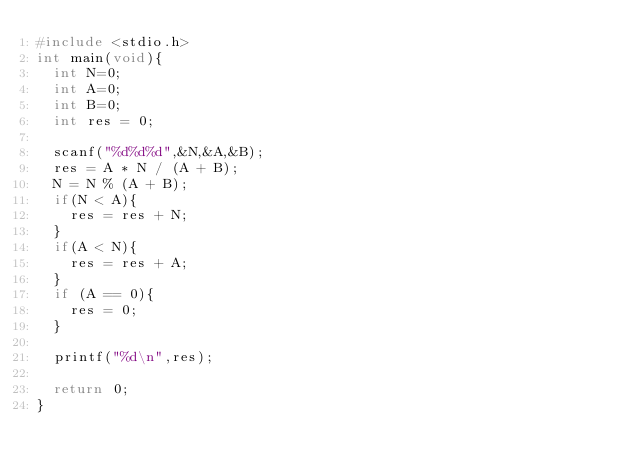<code> <loc_0><loc_0><loc_500><loc_500><_C_>#include <stdio.h>
int main(void){
	int N=0;
	int A=0;
	int B=0;
	int res = 0;
	
	scanf("%d%d%d",&N,&A,&B);
	res = A * N / (A + B);
	N = N % (A + B);
	if(N < A){
		res = res + N;
	}
	if(A < N){
		res = res + A;
	}
	if (A == 0){ 
		res = 0;
	}
	
	printf("%d\n",res);
	
	return 0;
}</code> 